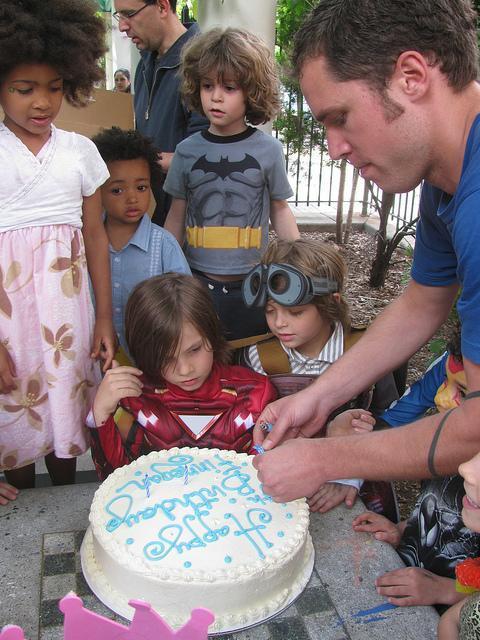How many people are in the photo?
Give a very brief answer. 7. How many dogs are on he bench in this image?
Give a very brief answer. 0. 